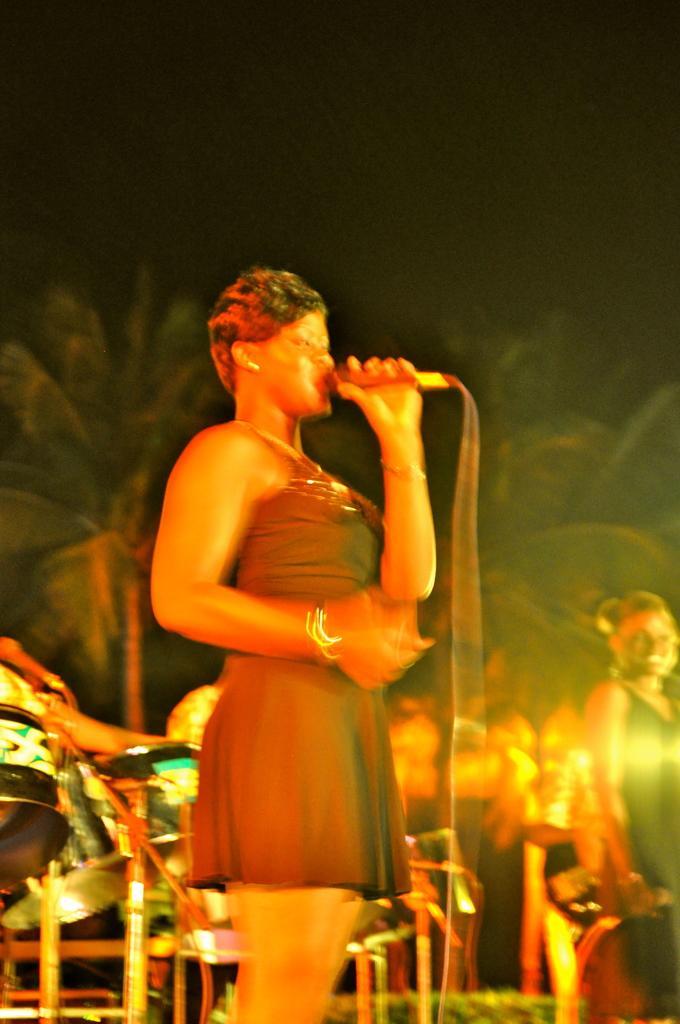Please provide a concise description of this image. In the image there is a woman, she is standing in singing and behind the women there are some music equipment and other people, in the background there are trees. 